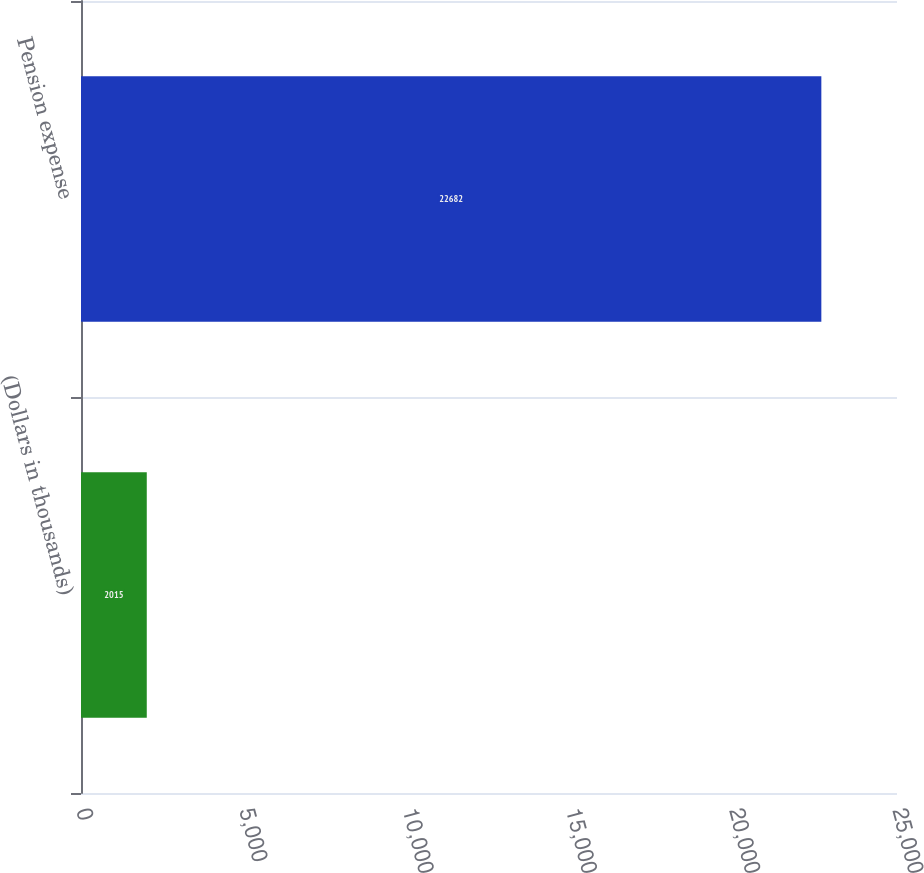Convert chart. <chart><loc_0><loc_0><loc_500><loc_500><bar_chart><fcel>(Dollars in thousands)<fcel>Pension expense<nl><fcel>2015<fcel>22682<nl></chart> 